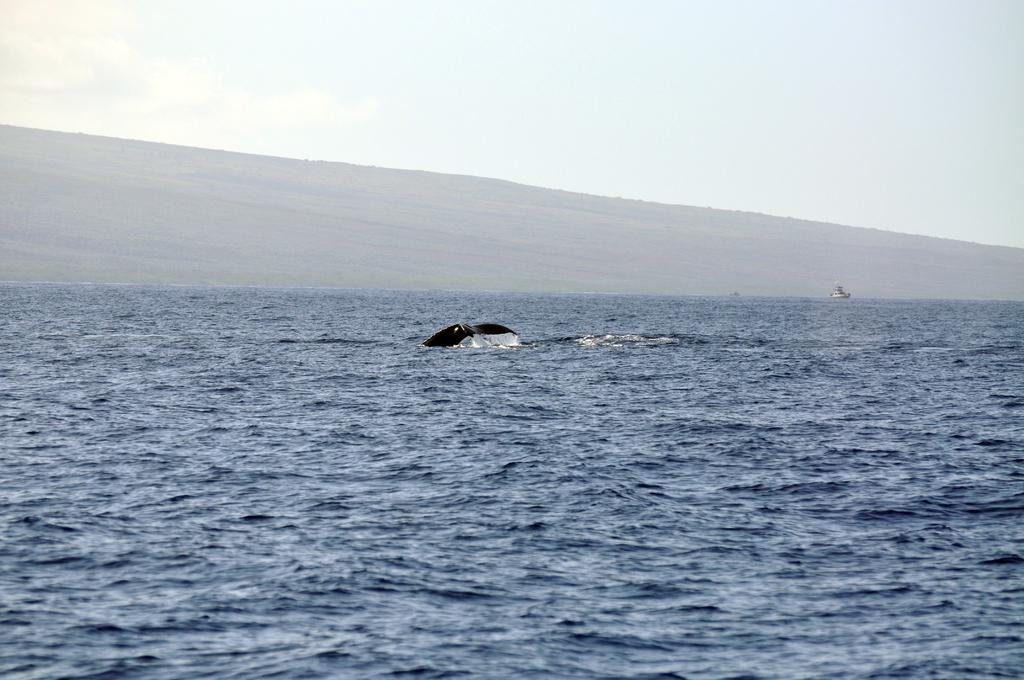What is the main feature of the image? There is a sea of blue water in the image. What can be seen floating on the water? There are things floating on the water in the image. What type of landscape is visible in the background? There are mountains visible at the top of the image. What color is the sky in the image? The sky is blue in the image. Where is the pear being judged in the image? There is no pear or judging scene present in the image. What type of coal is visible in the image? There is no coal present in the image. 